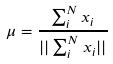Convert formula to latex. <formula><loc_0><loc_0><loc_500><loc_500>\mu = \frac { \sum _ { i } ^ { N } x _ { i } } { | | \sum _ { i } ^ { N } x _ { i } | | }</formula> 